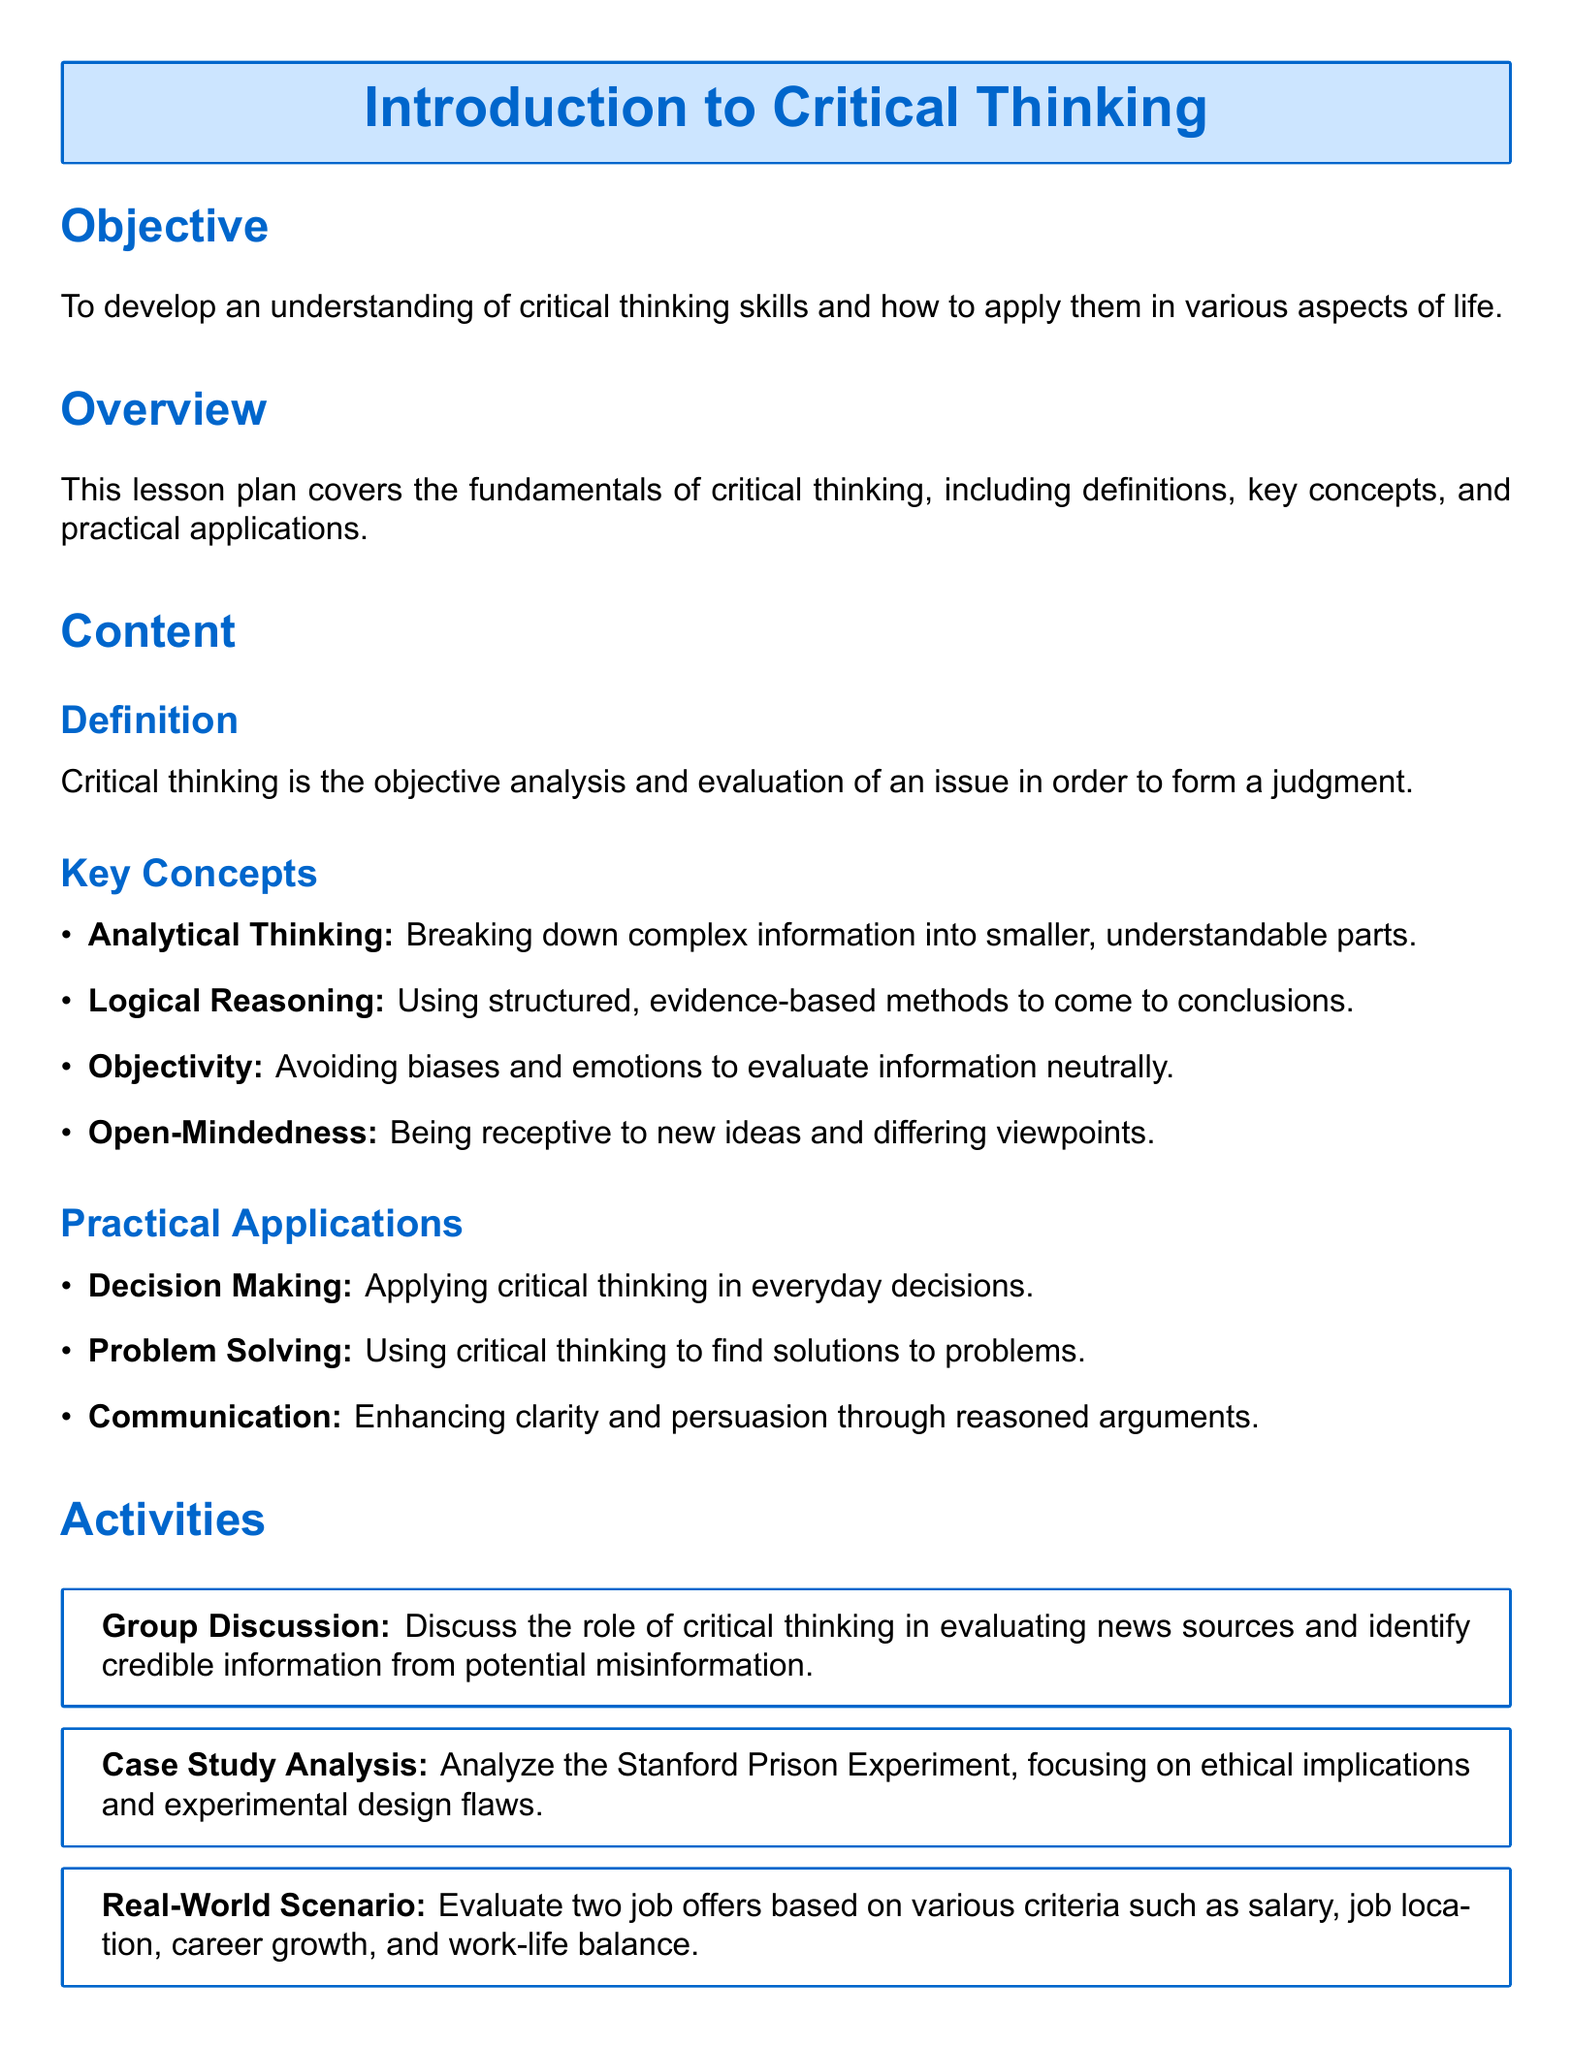What is the main objective of the lesson? The objective is stated clearly as developing an understanding of critical thinking skills and their application in various aspects of life.
Answer: Understanding critical thinking skills What is the title of the book mentioned in the resources? The resources section lists a specific book as a resource for learning more about critical thinking.
Answer: Think Critical, Think First What activity involves evaluating news sources? The document describes a group discussion as a specific activity related to this topic.
Answer: Group Discussion How many key concepts are listed in the content section? The number of key concepts is mentioned explicitly in the document.
Answer: Four What is the primary focus of the case study analysis activity? The document specifies that the case study analysis activity focuses on a well-known experiment and its implications.
Answer: Stanford Prison Experiment How are critical thinking skills assessed in this lesson plan? The assessment section outlines two specific methods for evaluating student understanding.
Answer: Written Reflection and Quiz What is one practical application of critical thinking mentioned? The document lists several areas where critical thinking can be applied, asking for an example.
Answer: Decision Making What color is used for the background of the title box? The document uses a specific color for the title box background, which is described in the formatting.
Answer: Second color 